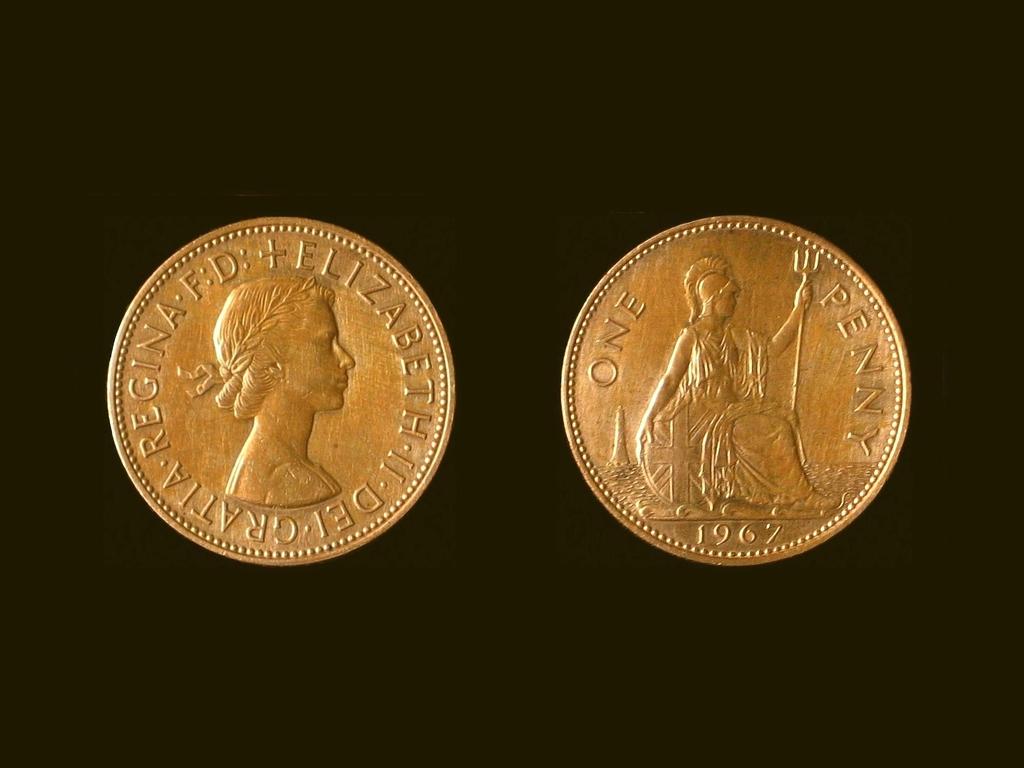What date is stamped on the coin?
Your answer should be compact. 1967. What type of coin is this?
Offer a terse response. Penny. 